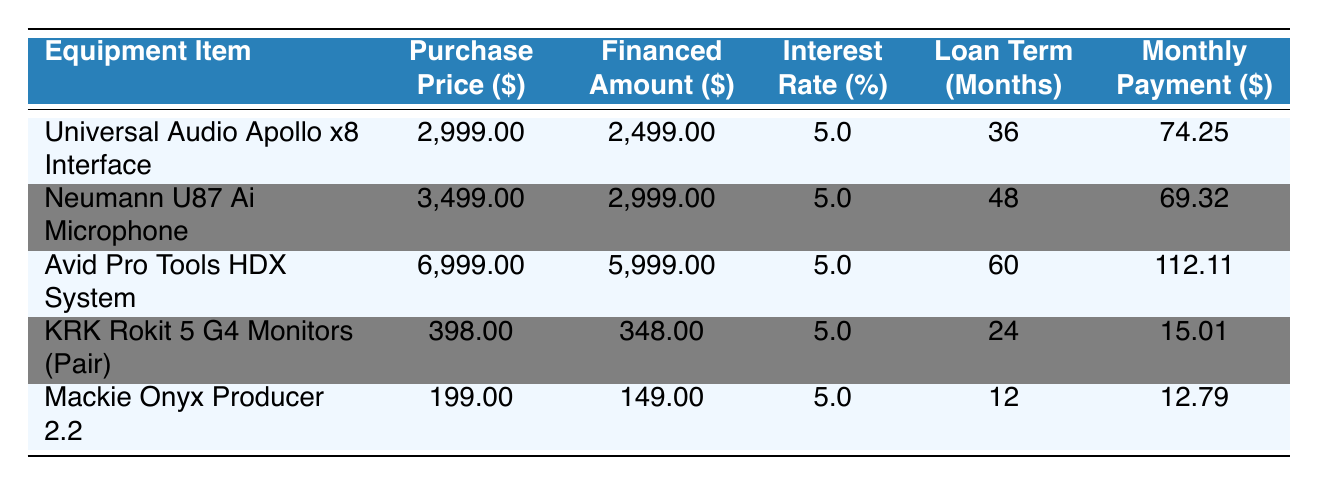What is the purchase price of the Neumann U87 Ai Microphone? The purchase price of the Neumann U87 Ai Microphone can be found in the table under the "Purchase Price ($)" column corresponding to that item. It shows $3,499.00.
Answer: $3,499.00 What is the total financed amount for all the equipment? To find the total financed amount, add the values in the "Financed Amount ($)" column: 2,499.00 + 2,999.00 + 5,999.00 + 348.00 + 149.00 = 12,994.00.
Answer: $12,994.00 Is the interest rate for the KRK Rokit 5 G4 Monitors higher than 5%? The interest rate for the KRK Rokit 5 G4 Monitors is listed as 5.0%. Therefore, it is not higher than 5%.
Answer: No Which item has the longest loan term, and what is that term? By looking at the "Loan Term (Months)" column, the Avid Pro Tools HDX System has the longest loan term of 60 months compared to the other items.
Answer: Avid Pro Tools HDX System, 60 months What is the difference in monthly payment between the Universal Audio Apollo x8 Interface and the Mackie Onyx Producer 2.2? The monthly payment for the Universal Audio Apollo x8 Interface is $74.25, and for the Mackie Onyx Producer 2.2 is $12.79. The difference is $74.25 - $12.79 = $61.46.
Answer: $61.46 